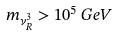<formula> <loc_0><loc_0><loc_500><loc_500>m _ { \nu _ { R } ^ { 3 } } > 1 0 ^ { 5 } \, G e V</formula> 